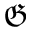Convert formula to latex. <formula><loc_0><loc_0><loc_500><loc_500>\mathfrak { G }</formula> 